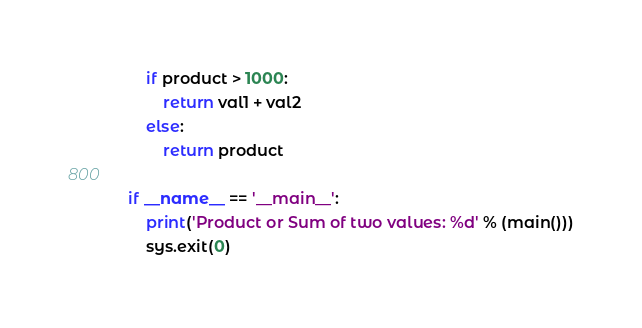Convert code to text. <code><loc_0><loc_0><loc_500><loc_500><_Python_>
    if product > 1000:
        return val1 + val2
    else:
        return product

if __name__ == '__main__':
    print('Product or Sum of two values: %d' % (main()))
    sys.exit(0)


</code> 